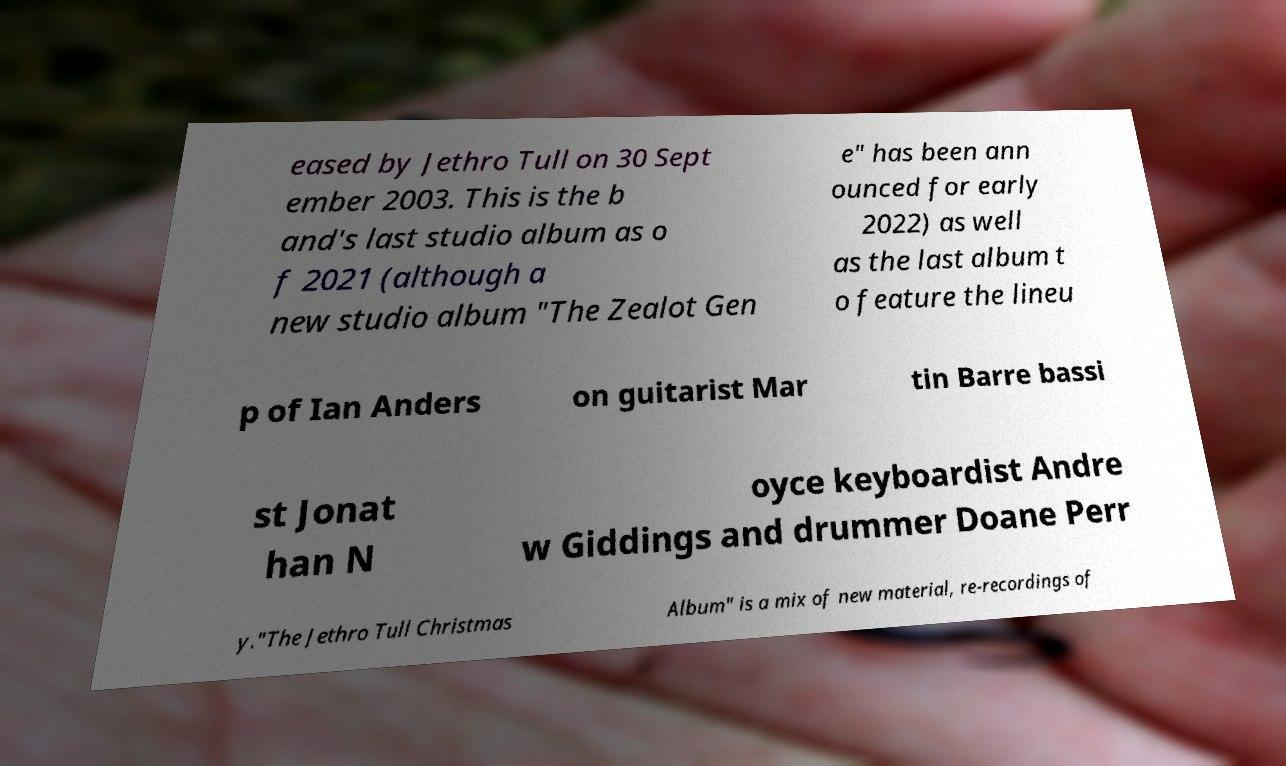For documentation purposes, I need the text within this image transcribed. Could you provide that? eased by Jethro Tull on 30 Sept ember 2003. This is the b and's last studio album as o f 2021 (although a new studio album "The Zealot Gen e" has been ann ounced for early 2022) as well as the last album t o feature the lineu p of Ian Anders on guitarist Mar tin Barre bassi st Jonat han N oyce keyboardist Andre w Giddings and drummer Doane Perr y."The Jethro Tull Christmas Album" is a mix of new material, re-recordings of 